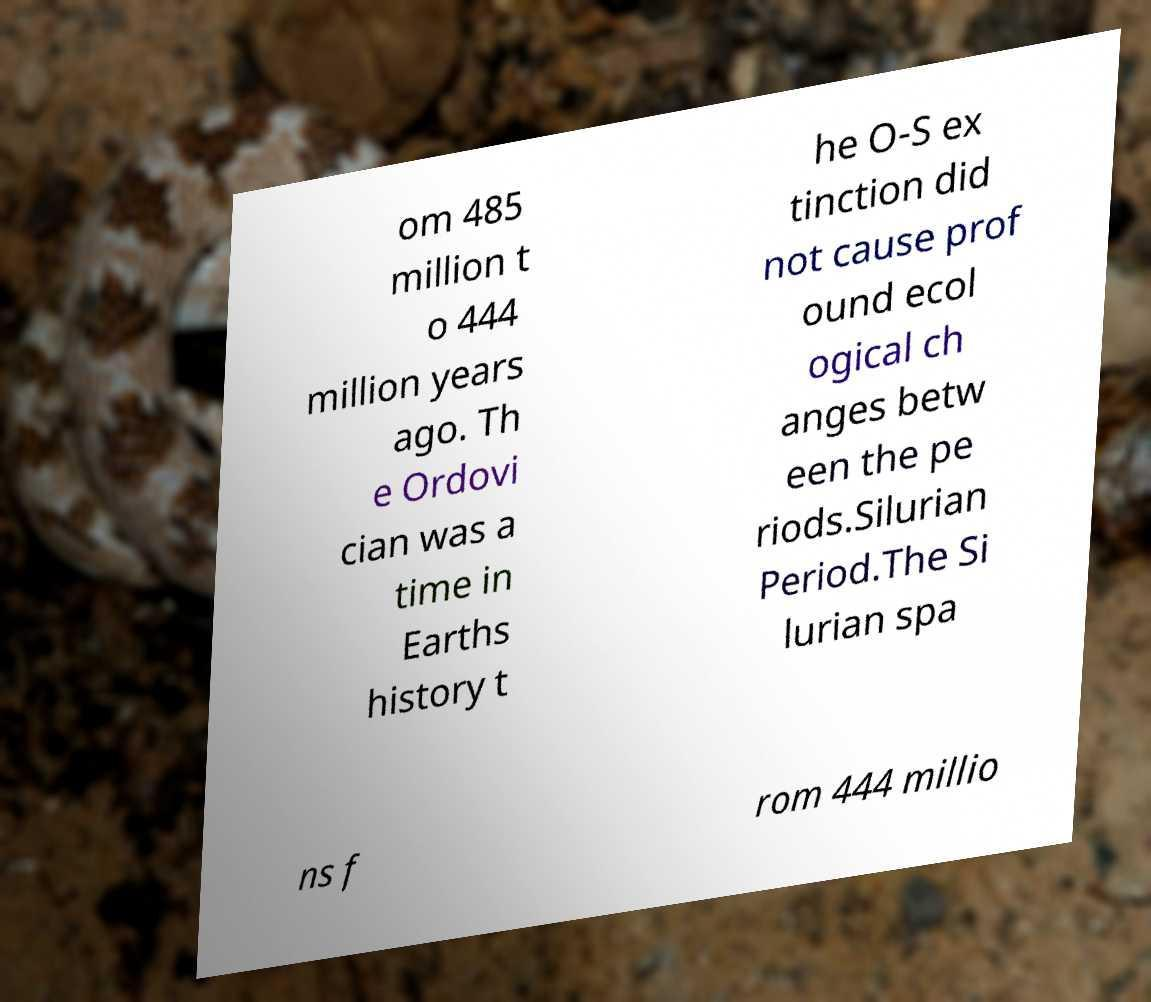Please read and relay the text visible in this image. What does it say? om 485 million t o 444 million years ago. Th e Ordovi cian was a time in Earths history t he O-S ex tinction did not cause prof ound ecol ogical ch anges betw een the pe riods.Silurian Period.The Si lurian spa ns f rom 444 millio 